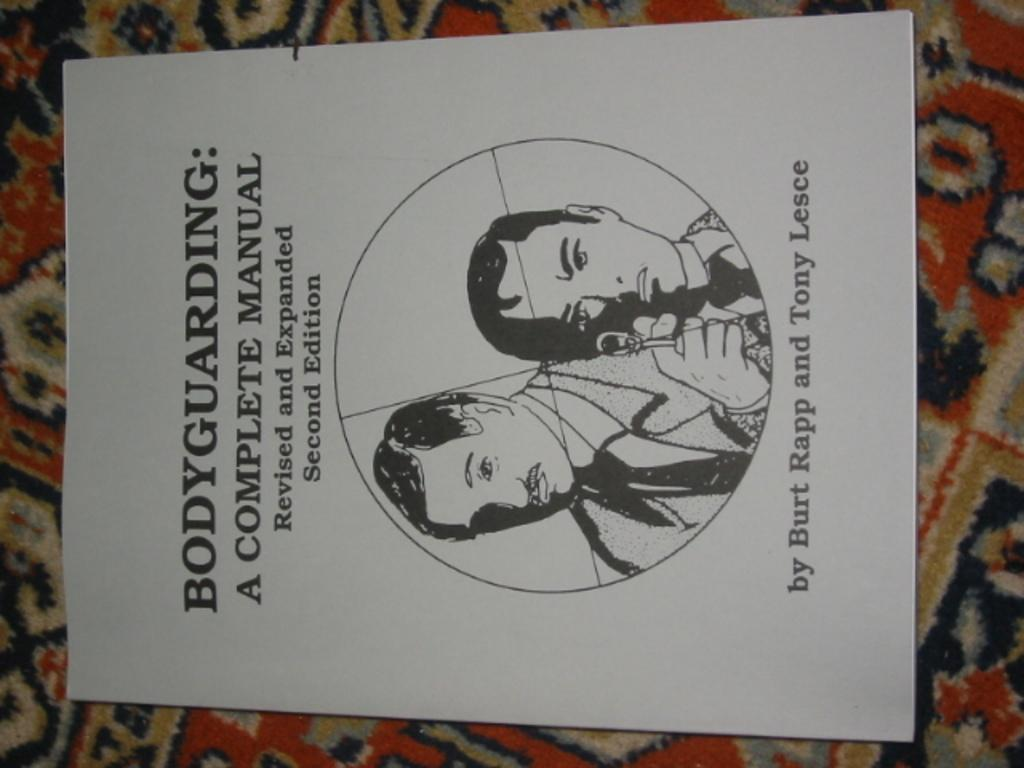<image>
Describe the image concisely. A book by Burt Rapp and Tony Lesce called Bodyguarding: A Complete Manual. 